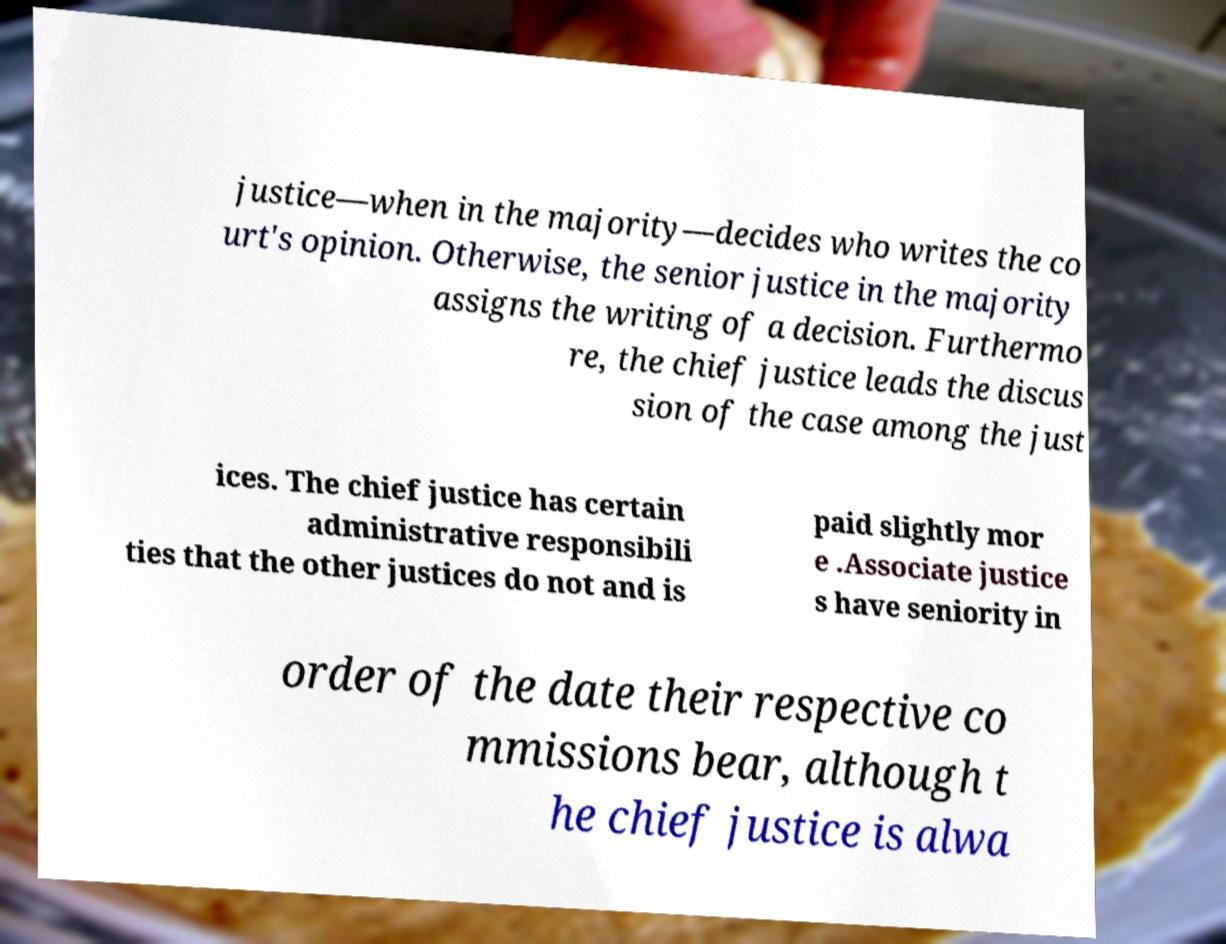Can you read and provide the text displayed in the image?This photo seems to have some interesting text. Can you extract and type it out for me? justice—when in the majority—decides who writes the co urt's opinion. Otherwise, the senior justice in the majority assigns the writing of a decision. Furthermo re, the chief justice leads the discus sion of the case among the just ices. The chief justice has certain administrative responsibili ties that the other justices do not and is paid slightly mor e .Associate justice s have seniority in order of the date their respective co mmissions bear, although t he chief justice is alwa 